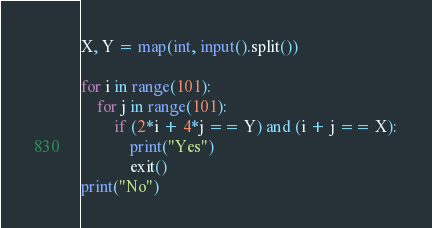Convert code to text. <code><loc_0><loc_0><loc_500><loc_500><_Python_>X, Y = map(int, input().split())

for i in range(101):
    for j in range(101):
        if (2*i + 4*j == Y) and (i + j == X):
            print("Yes")
            exit()
print("No")</code> 